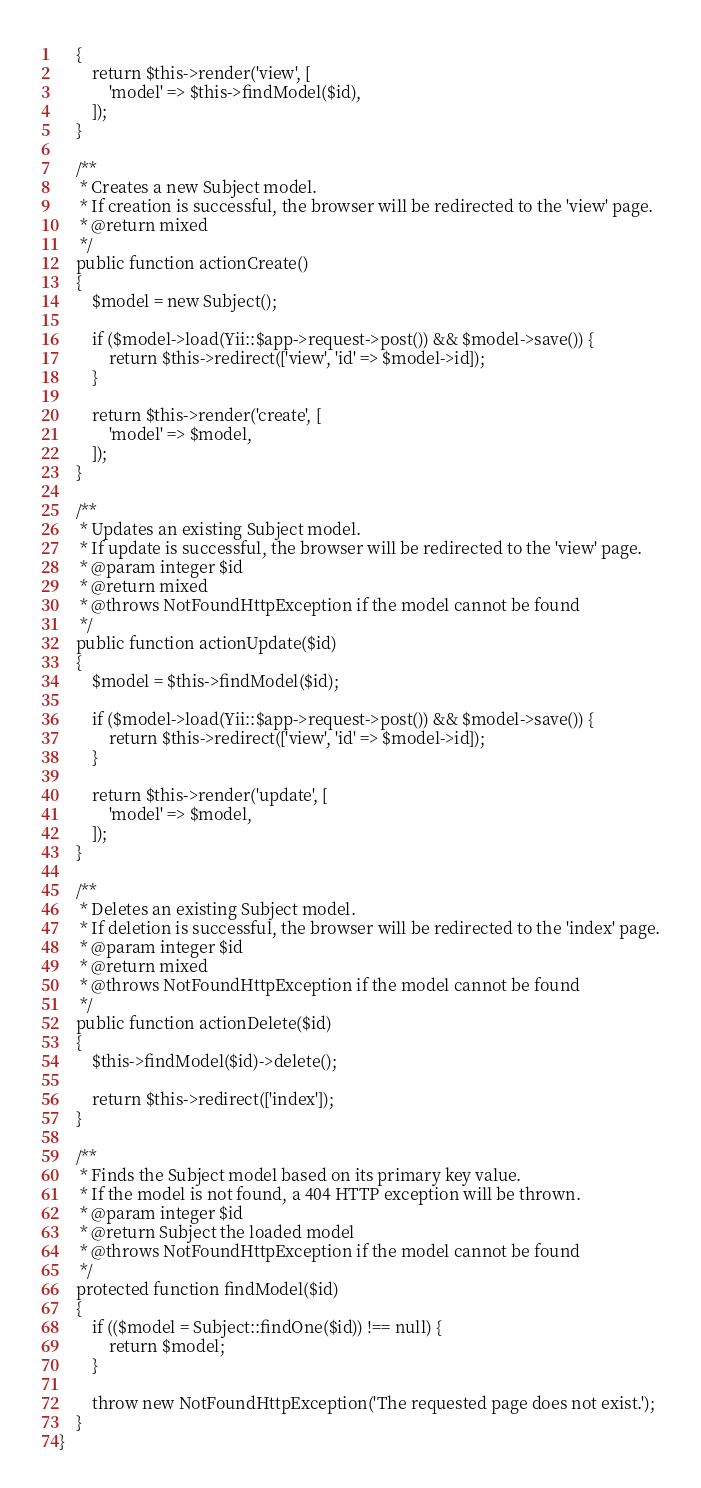<code> <loc_0><loc_0><loc_500><loc_500><_PHP_>    {
        return $this->render('view', [
            'model' => $this->findModel($id),
        ]);
    }

    /**
     * Creates a new Subject model.
     * If creation is successful, the browser will be redirected to the 'view' page.
     * @return mixed
     */
    public function actionCreate()
    {
        $model = new Subject();

        if ($model->load(Yii::$app->request->post()) && $model->save()) {
            return $this->redirect(['view', 'id' => $model->id]);
        }

        return $this->render('create', [
            'model' => $model,
        ]);
    }

    /**
     * Updates an existing Subject model.
     * If update is successful, the browser will be redirected to the 'view' page.
     * @param integer $id
     * @return mixed
     * @throws NotFoundHttpException if the model cannot be found
     */
    public function actionUpdate($id)
    {
        $model = $this->findModel($id);

        if ($model->load(Yii::$app->request->post()) && $model->save()) {
            return $this->redirect(['view', 'id' => $model->id]);
        }

        return $this->render('update', [
            'model' => $model,
        ]);
    }

    /**
     * Deletes an existing Subject model.
     * If deletion is successful, the browser will be redirected to the 'index' page.
     * @param integer $id
     * @return mixed
     * @throws NotFoundHttpException if the model cannot be found
     */
    public function actionDelete($id)
    {
        $this->findModel($id)->delete();

        return $this->redirect(['index']);
    }

    /**
     * Finds the Subject model based on its primary key value.
     * If the model is not found, a 404 HTTP exception will be thrown.
     * @param integer $id
     * @return Subject the loaded model
     * @throws NotFoundHttpException if the model cannot be found
     */
    protected function findModel($id)
    {
        if (($model = Subject::findOne($id)) !== null) {
            return $model;
        }

        throw new NotFoundHttpException('The requested page does not exist.');
    }
}
</code> 